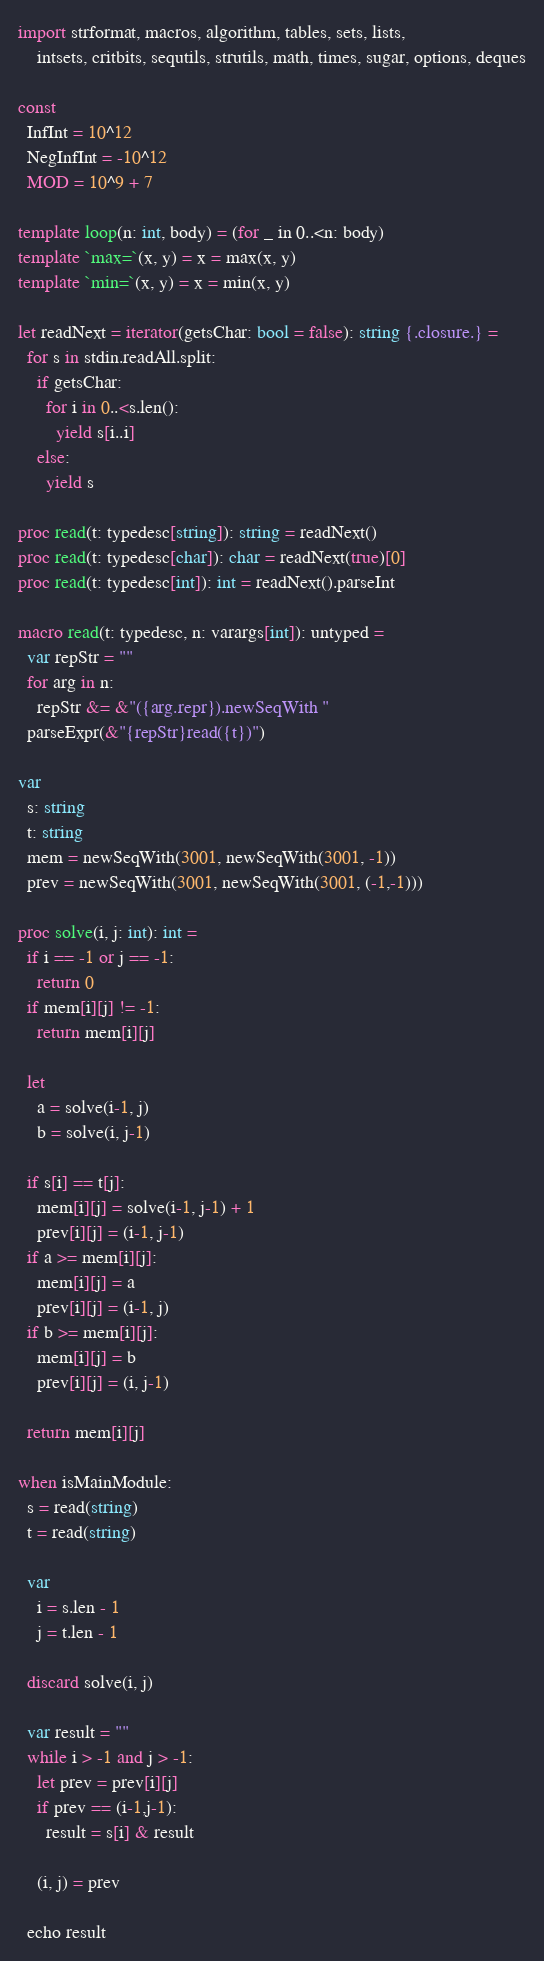<code> <loc_0><loc_0><loc_500><loc_500><_Nim_>import strformat, macros, algorithm, tables, sets, lists,
    intsets, critbits, sequtils, strutils, math, times, sugar, options, deques

const
  InfInt = 10^12
  NegInfInt = -10^12
  MOD = 10^9 + 7

template loop(n: int, body) = (for _ in 0..<n: body)
template `max=`(x, y) = x = max(x, y)
template `min=`(x, y) = x = min(x, y)

let readNext = iterator(getsChar: bool = false): string {.closure.} =
  for s in stdin.readAll.split:
    if getsChar:
      for i in 0..<s.len():
        yield s[i..i]
    else:
      yield s

proc read(t: typedesc[string]): string = readNext()
proc read(t: typedesc[char]): char = readNext(true)[0]
proc read(t: typedesc[int]): int = readNext().parseInt

macro read(t: typedesc, n: varargs[int]): untyped =
  var repStr = ""
  for arg in n:
    repStr &= &"({arg.repr}).newSeqWith "
  parseExpr(&"{repStr}read({t})")

var
  s: string
  t: string
  mem = newSeqWith(3001, newSeqWith(3001, -1))
  prev = newSeqWith(3001, newSeqWith(3001, (-1,-1)))

proc solve(i, j: int): int =
  if i == -1 or j == -1:
    return 0
  if mem[i][j] != -1:
    return mem[i][j]

  let
    a = solve(i-1, j)
    b = solve(i, j-1)

  if s[i] == t[j]:
    mem[i][j] = solve(i-1, j-1) + 1
    prev[i][j] = (i-1, j-1)
  if a >= mem[i][j]:
    mem[i][j] = a
    prev[i][j] = (i-1, j)
  if b >= mem[i][j]:
    mem[i][j] = b
    prev[i][j] = (i, j-1)

  return mem[i][j]

when isMainModule:
  s = read(string)
  t = read(string)

  var
    i = s.len - 1
    j = t.len - 1

  discard solve(i, j)

  var result = ""
  while i > -1 and j > -1:
    let prev = prev[i][j]
    if prev == (i-1,j-1):
      result = s[i] & result

    (i, j) = prev

  echo result
</code> 